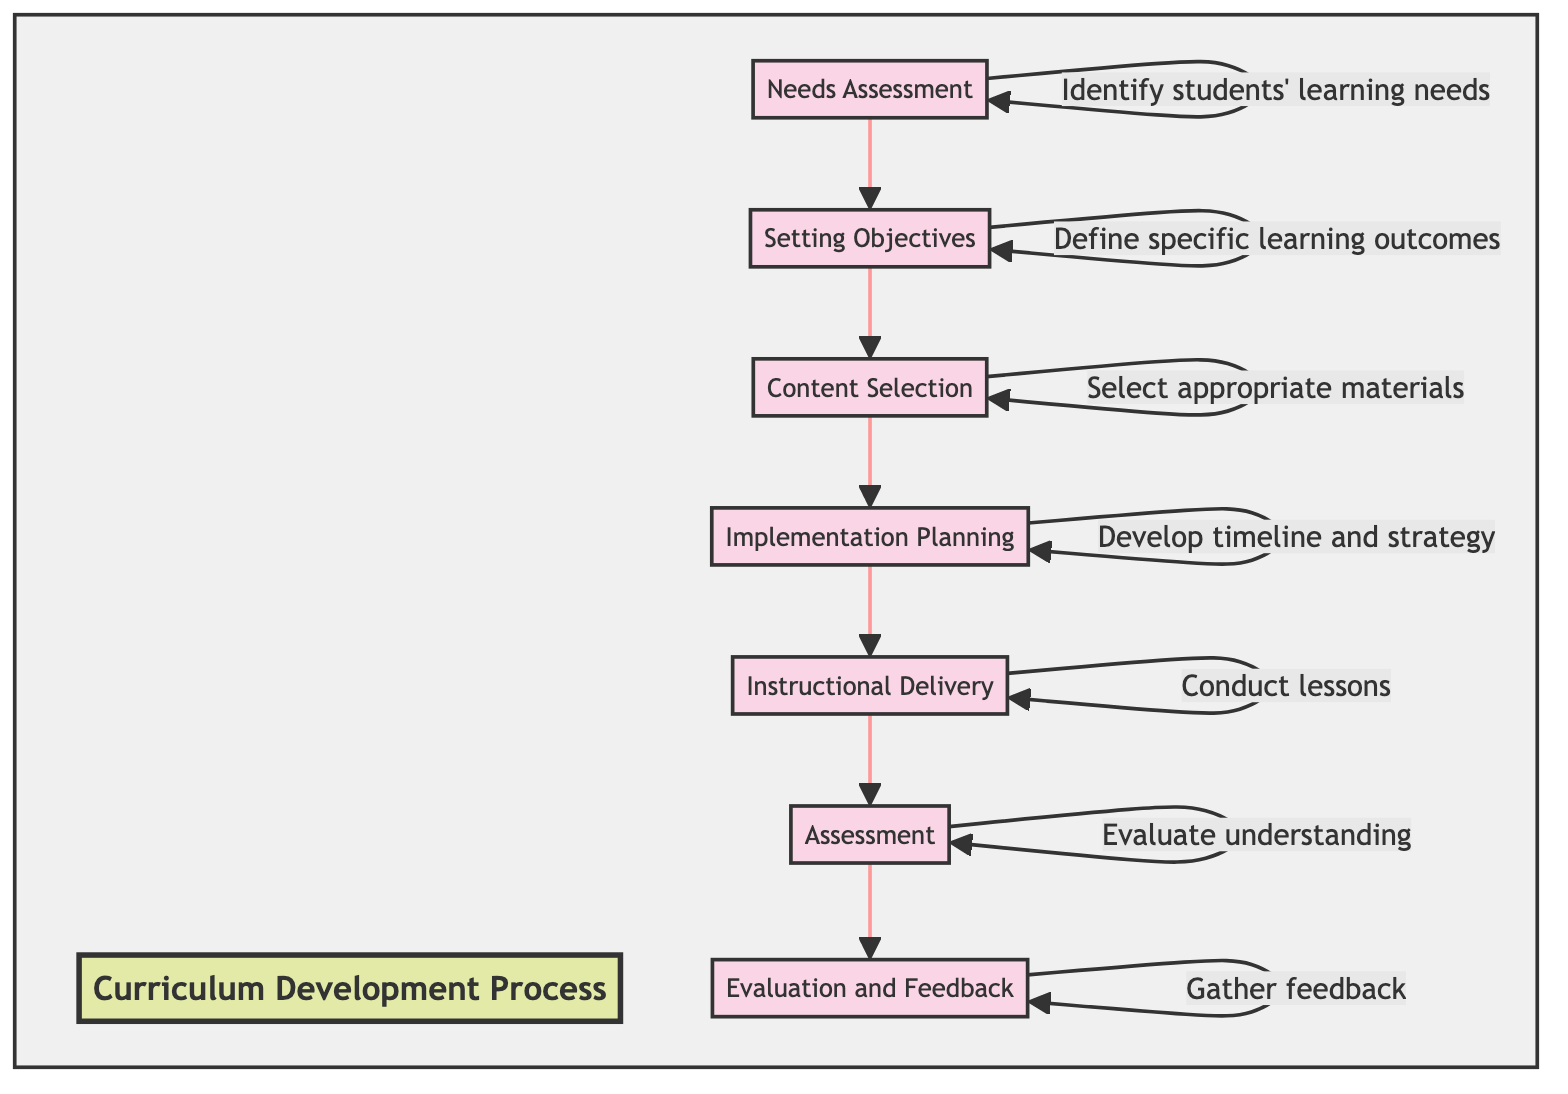What is the first stage in the Curriculum Development Process? The first stage in the diagram is "Needs Assessment," which is the initial step before all others in the flowchart.
Answer: Needs Assessment How many stages are there in the Curriculum Development Process? By counting the different stages listed in the diagram, there are a total of seven distinct stages in the process.
Answer: 7 What stage follows Content Selection? Looking at the flow direction in the diagram, "Implementation Planning" follows directly after "Content Selection."
Answer: Implementation Planning Which stage involves evaluating student understanding? The diagram specifies that "Assessment" is the stage where the evaluation of student understanding occurs.
Answer: Assessment What is the last stage of the Curriculum Development Process? The last stage in the flowchart is "Evaluation and Feedback," indicating the end of the process.
Answer: Evaluation and Feedback What action is associated with the "Implementation Planning" stage? The diagram states that in the "Implementation Planning" stage, the key action is to "Develop a timeline and strategy."
Answer: Develop a timeline and strategy What stage comes before Setting Objectives? Reviewing the flow in the diagram, "Needs Assessment" comes before "Setting Objectives" in the sequence of stages.
Answer: Needs Assessment Which two stages directly lead to gathering feedback to improve the curriculum? The diagram indicates that "Assessment" leads to "Evaluation and Feedback," which involves gathering feedback from students and educators.
Answer: Assessment and Evaluation and Feedback 